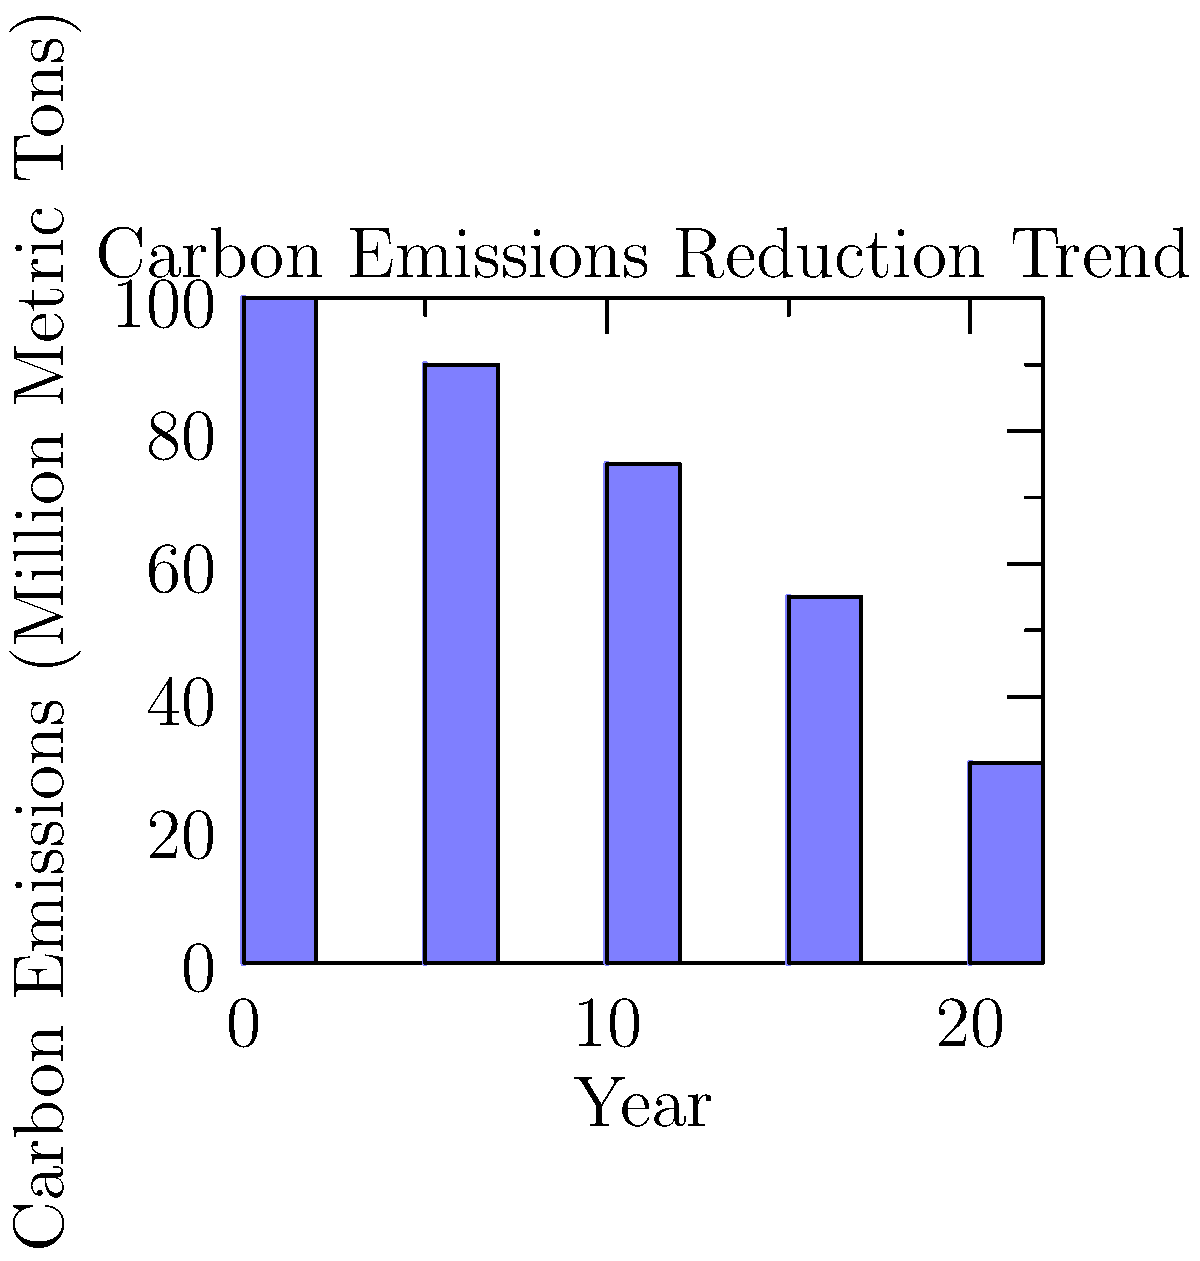Based on the bar graph showing the trend of carbon emissions reduction over time, what is the expected percentage decrease in carbon emissions from 2010 to 2030? To calculate the percentage decrease in carbon emissions from 2010 to 2030:

1. Identify the carbon emissions values:
   2010: 100 million metric tons
   2030: 30 million metric tons

2. Calculate the decrease in emissions:
   Decrease = 100 - 30 = 70 million metric tons

3. Calculate the percentage decrease:
   Percentage decrease = (Decrease / Original Value) × 100
   = (70 / 100) × 100
   = 0.7 × 100
   = 70%

Therefore, the expected percentage decrease in carbon emissions from 2010 to 2030 is 70%.
Answer: 70% 